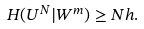Convert formula to latex. <formula><loc_0><loc_0><loc_500><loc_500>H ( U ^ { N } | W ^ { m } ) \geq N h .</formula> 